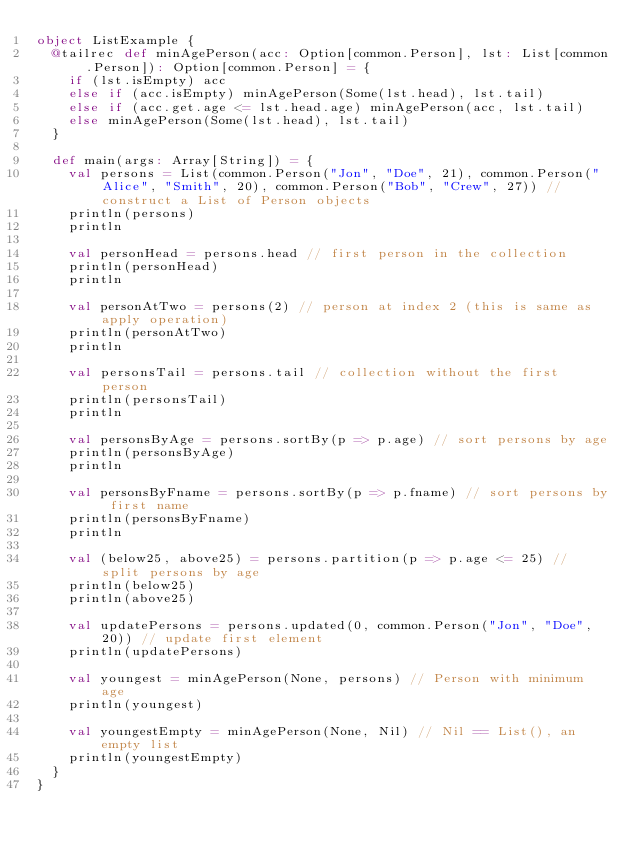<code> <loc_0><loc_0><loc_500><loc_500><_Scala_>object ListExample {
  @tailrec def minAgePerson(acc: Option[common.Person], lst: List[common.Person]): Option[common.Person] = {
    if (lst.isEmpty) acc
    else if (acc.isEmpty) minAgePerson(Some(lst.head), lst.tail)
    else if (acc.get.age <= lst.head.age) minAgePerson(acc, lst.tail)
    else minAgePerson(Some(lst.head), lst.tail)
  }

  def main(args: Array[String]) = {
    val persons = List(common.Person("Jon", "Doe", 21), common.Person("Alice", "Smith", 20), common.Person("Bob", "Crew", 27)) // construct a List of Person objects
    println(persons)
    println

    val personHead = persons.head // first person in the collection
    println(personHead)
    println

    val personAtTwo = persons(2) // person at index 2 (this is same as apply operation)
    println(personAtTwo)
    println

    val personsTail = persons.tail // collection without the first person
    println(personsTail)
    println

    val personsByAge = persons.sortBy(p => p.age) // sort persons by age
    println(personsByAge)
    println

    val personsByFname = persons.sortBy(p => p.fname) // sort persons by first name
    println(personsByFname)
    println

    val (below25, above25) = persons.partition(p => p.age <= 25) // split persons by age
    println(below25)
    println(above25)

    val updatePersons = persons.updated(0, common.Person("Jon", "Doe", 20)) // update first element
    println(updatePersons)

    val youngest = minAgePerson(None, persons) // Person with minimum age
    println(youngest)

    val youngestEmpty = minAgePerson(None, Nil) // Nil == List(), an empty list
    println(youngestEmpty)
  }
}
</code> 